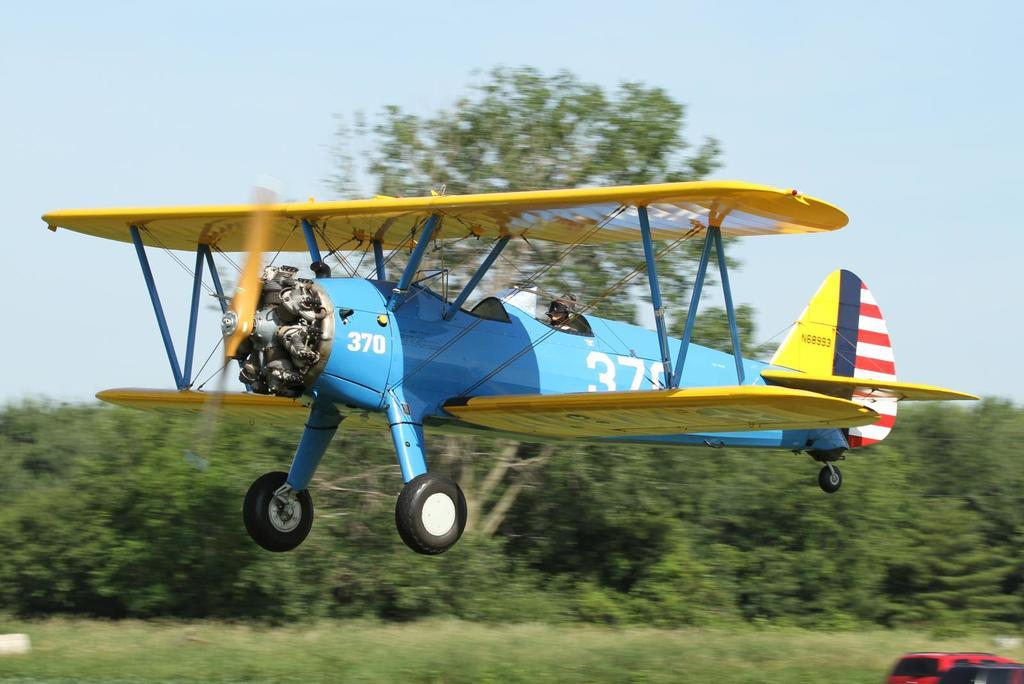<image>
Present a compact description of the photo's key features. a blue and yellow old prop plane number 370 is flying near the ground 